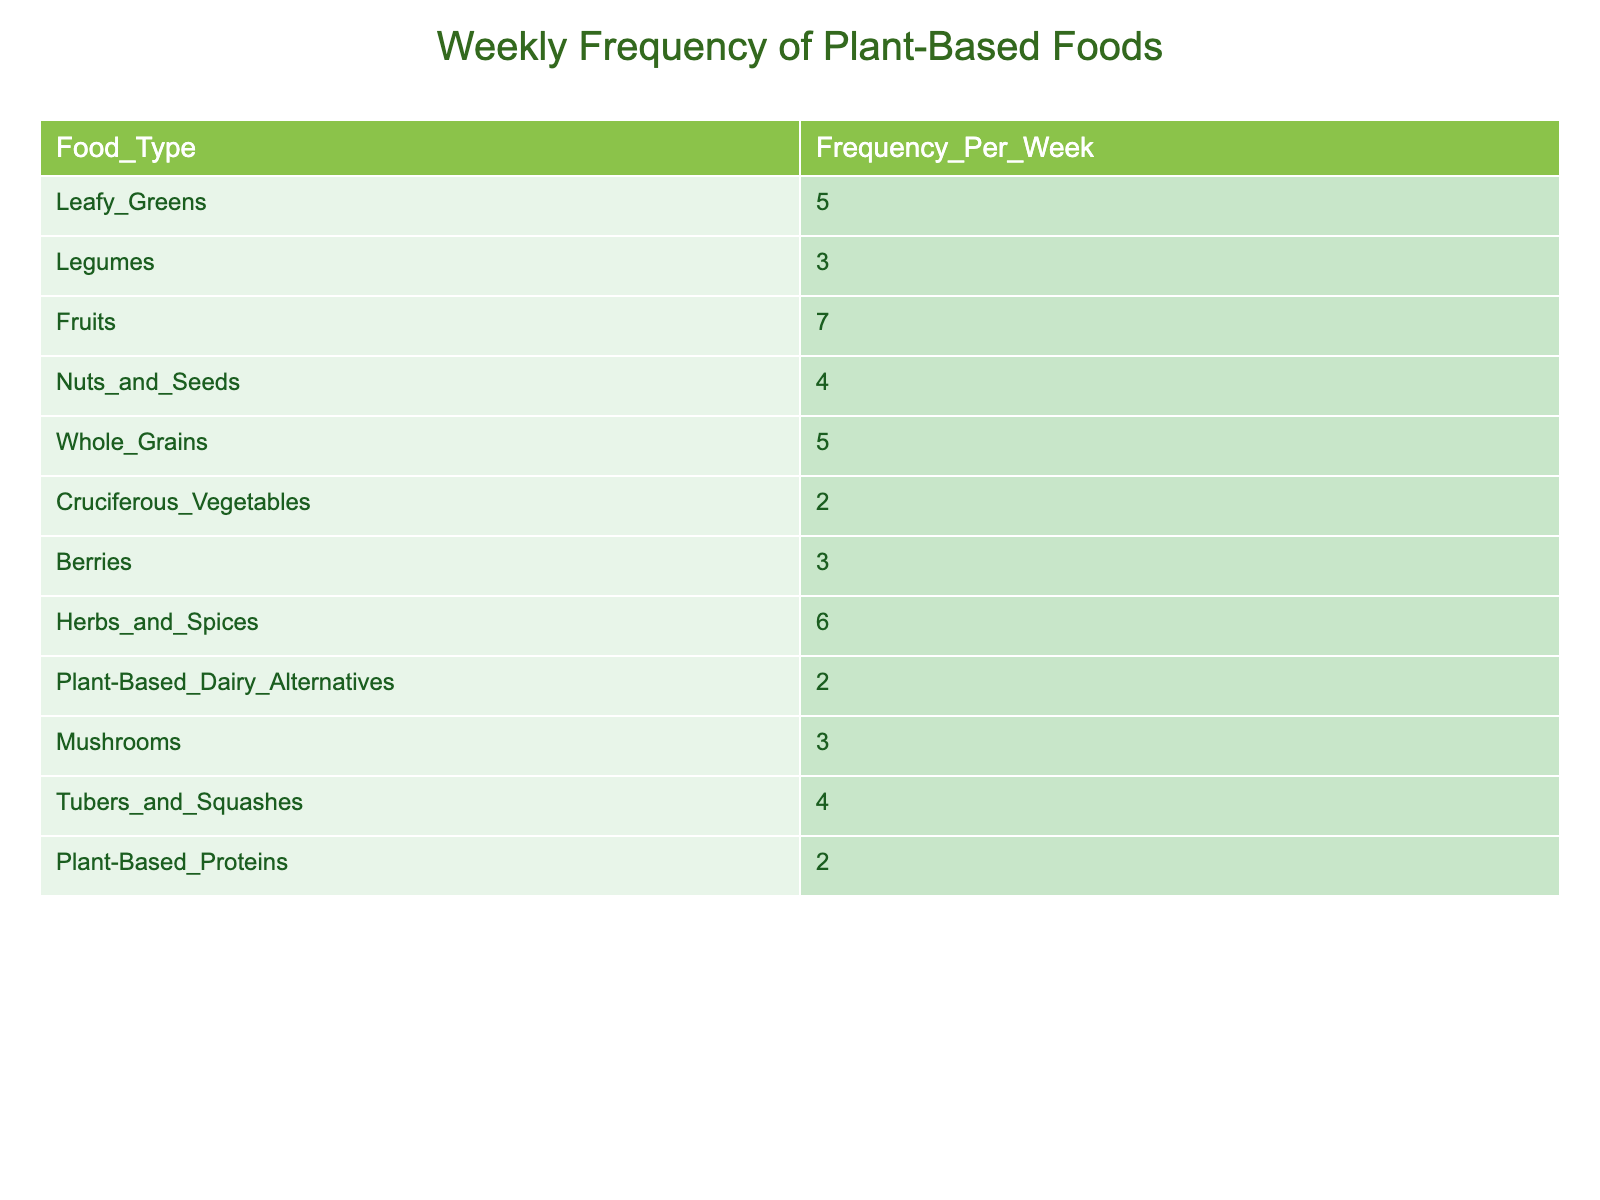What is the frequency of fruits consumed weekly? The table lists the frequency for each food type, and for fruits, it clearly shows a frequency of 7.
Answer: 7 Which type of plant-based food has the highest consumption frequency? Looking at the table, fruits have the highest frequency at 7, which is greater than any other food type listed.
Answer: Fruits What is the total frequency of leafy greens and whole grains combined? The frequency for leafy greens is 5 and for whole grains is also 5. Adding these together gives 5 + 5 = 10.
Answer: 10 Is the frequency of nuts and seeds higher than that of cruciferous vegetables? The frequency for nuts and seeds is 4, while for cruciferous vegetables, it is 2. Since 4 is greater than 2, the statement is true.
Answer: Yes What is the average frequency of legumes, berries, and mushrooms consumed weekly? The frequencies for legumes, berries, and mushrooms are 3, 3, and 3 respectively. Adding these gives 3 + 3 + 3 = 9. There are 3 items, and 9 divided by 3 equals 3.
Answer: 3 How many more times do you consume fruits compared to plant-based proteins? The frequency for fruits is 7 and for plant-based proteins is 2. The difference between them is 7 - 2 = 5.
Answer: 5 Are there any plant-based food types that have the same frequency? Upon examining the table, both berries and mushrooms share the same frequency of 3, confirming that there are food types with identical frequencies.
Answer: Yes What percentage of the total frequency is attributed to herbs and spices? First, calculate the total frequency by adding all frequencies: 5 + 3 + 7 + 4 + 5 + 2 + 3 + 6 + 2 + 3 + 4 + 2 = 46. The frequency for herbs and spices is 6. The percentage is then calculated as (6/46) * 100, which equals approximately 13.04%.
Answer: 13.04% Which food type is consumed at least 3 times a week? The food types with a frequency of 3 or more are leafy greens (5), fruits (7), nuts and seeds (4), whole grains (5), herbs and spices (6), mushrooms (3), and tubers and squashes (4), confirming there are several foods consumed at this rate.
Answer: Multiple types 